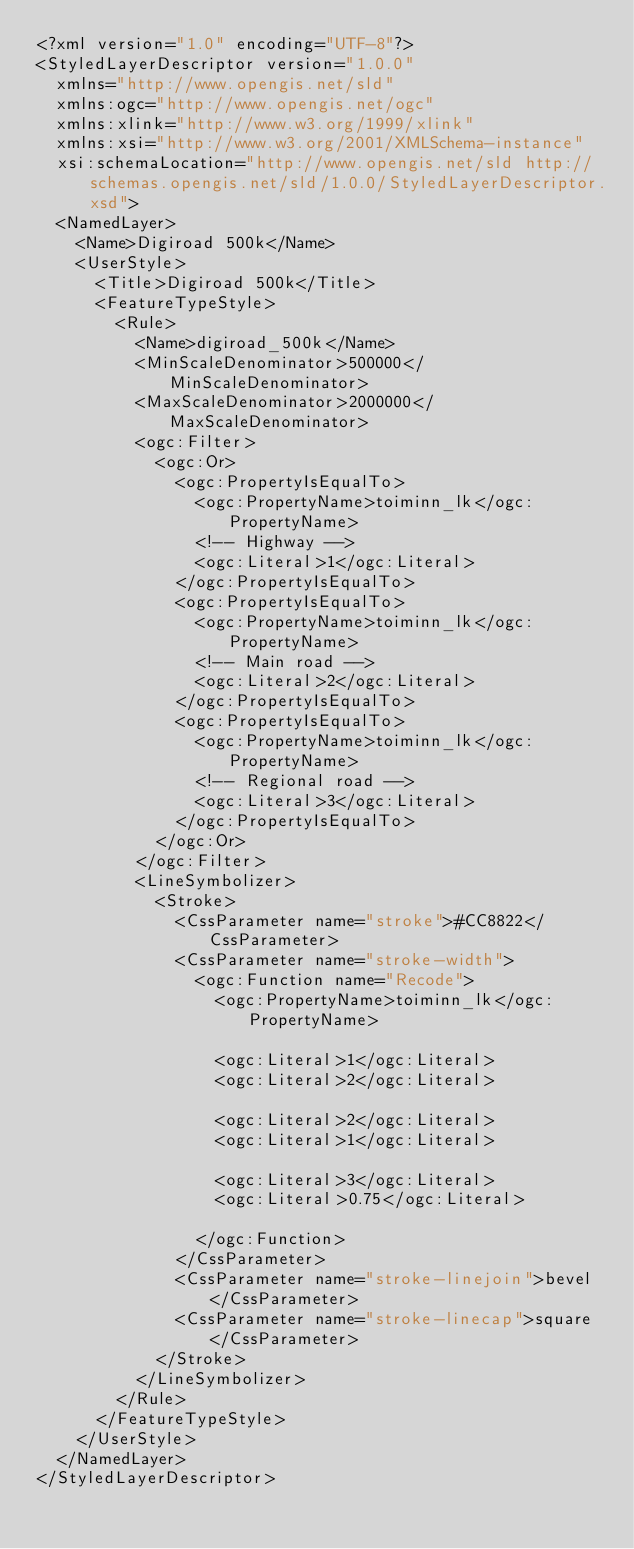<code> <loc_0><loc_0><loc_500><loc_500><_Scheme_><?xml version="1.0" encoding="UTF-8"?>
<StyledLayerDescriptor version="1.0.0"
  xmlns="http://www.opengis.net/sld"
  xmlns:ogc="http://www.opengis.net/ogc"
  xmlns:xlink="http://www.w3.org/1999/xlink"
  xmlns:xsi="http://www.w3.org/2001/XMLSchema-instance"
  xsi:schemaLocation="http://www.opengis.net/sld http://schemas.opengis.net/sld/1.0.0/StyledLayerDescriptor.xsd">
  <NamedLayer>
    <Name>Digiroad 500k</Name>
    <UserStyle>
      <Title>Digiroad 500k</Title>
      <FeatureTypeStyle>
        <Rule>
          <Name>digiroad_500k</Name>
          <MinScaleDenominator>500000</MinScaleDenominator>
          <MaxScaleDenominator>2000000</MaxScaleDenominator>
          <ogc:Filter>
            <ogc:Or>
              <ogc:PropertyIsEqualTo>
                <ogc:PropertyName>toiminn_lk</ogc:PropertyName>
                <!-- Highway -->
                <ogc:Literal>1</ogc:Literal>
              </ogc:PropertyIsEqualTo>
              <ogc:PropertyIsEqualTo>
                <ogc:PropertyName>toiminn_lk</ogc:PropertyName>
                <!-- Main road -->
                <ogc:Literal>2</ogc:Literal>
              </ogc:PropertyIsEqualTo>
              <ogc:PropertyIsEqualTo>
                <ogc:PropertyName>toiminn_lk</ogc:PropertyName>
                <!-- Regional road -->
                <ogc:Literal>3</ogc:Literal>
              </ogc:PropertyIsEqualTo>
            </ogc:Or>
          </ogc:Filter>
          <LineSymbolizer>
            <Stroke>
              <CssParameter name="stroke">#CC8822</CssParameter>
              <CssParameter name="stroke-width">
                <ogc:Function name="Recode">
                  <ogc:PropertyName>toiminn_lk</ogc:PropertyName>

                  <ogc:Literal>1</ogc:Literal>
                  <ogc:Literal>2</ogc:Literal>

                  <ogc:Literal>2</ogc:Literal>
                  <ogc:Literal>1</ogc:Literal>

                  <ogc:Literal>3</ogc:Literal>
                  <ogc:Literal>0.75</ogc:Literal>

                </ogc:Function>
              </CssParameter>
              <CssParameter name="stroke-linejoin">bevel</CssParameter>
              <CssParameter name="stroke-linecap">square</CssParameter>
            </Stroke>
          </LineSymbolizer>
        </Rule>
      </FeatureTypeStyle>
    </UserStyle>
  </NamedLayer>
</StyledLayerDescriptor>
</code> 